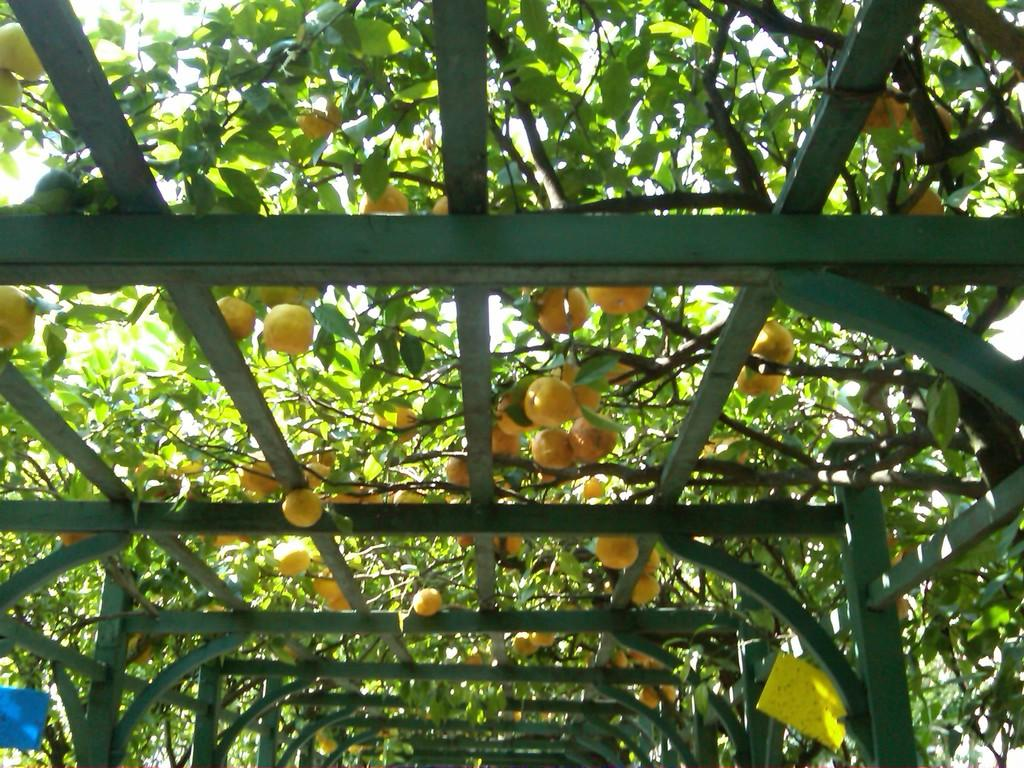What type of objects can be seen in the image that are made of metal? There are metallic poles in the image. What type of plants are present in the image that have fruits? There are trees with fruits in the image. What type of flat, rigid material can be seen in the image? There are boards in the image in the image. What part of the natural environment is visible in the image set against? The sky is visible in the image. How many steps are visible in the image? A: There are no steps present in the image. What type of shelter is shown in the image? There is no tent or any other type of shelter present in the image. 